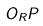<formula> <loc_0><loc_0><loc_500><loc_500>O _ { R } P</formula> 